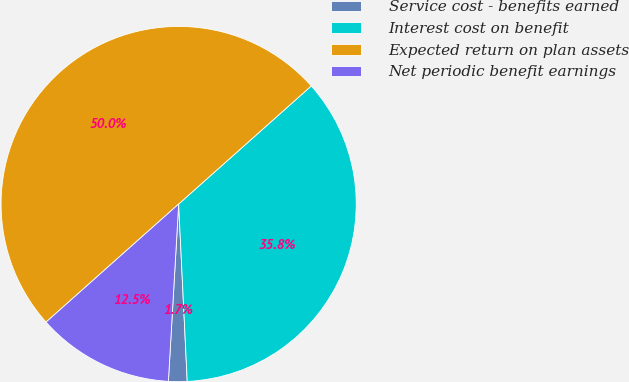Convert chart to OTSL. <chart><loc_0><loc_0><loc_500><loc_500><pie_chart><fcel>Service cost - benefits earned<fcel>Interest cost on benefit<fcel>Expected return on plan assets<fcel>Net periodic benefit earnings<nl><fcel>1.69%<fcel>35.81%<fcel>50.0%<fcel>12.5%<nl></chart> 